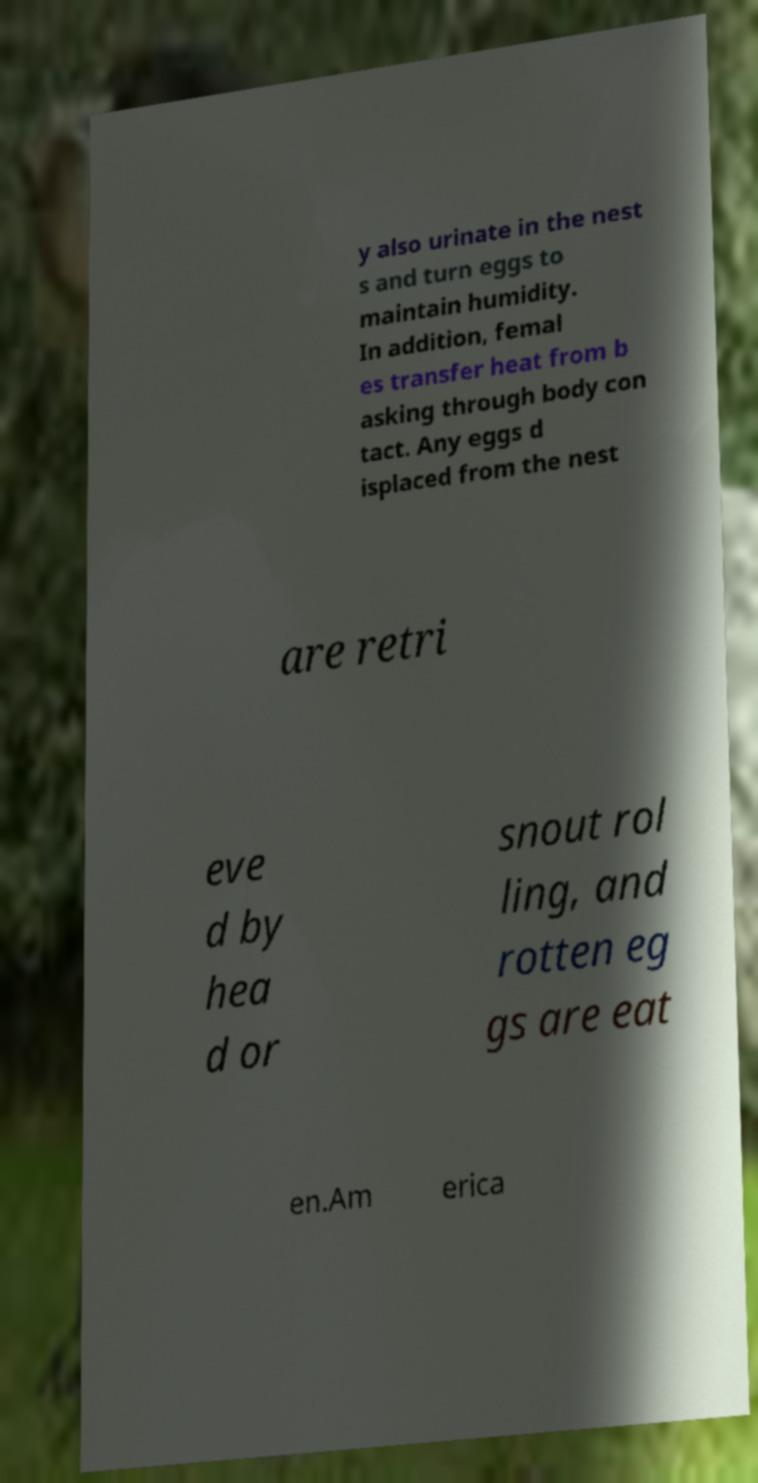Can you read and provide the text displayed in the image?This photo seems to have some interesting text. Can you extract and type it out for me? y also urinate in the nest s and turn eggs to maintain humidity. In addition, femal es transfer heat from b asking through body con tact. Any eggs d isplaced from the nest are retri eve d by hea d or snout rol ling, and rotten eg gs are eat en.Am erica 